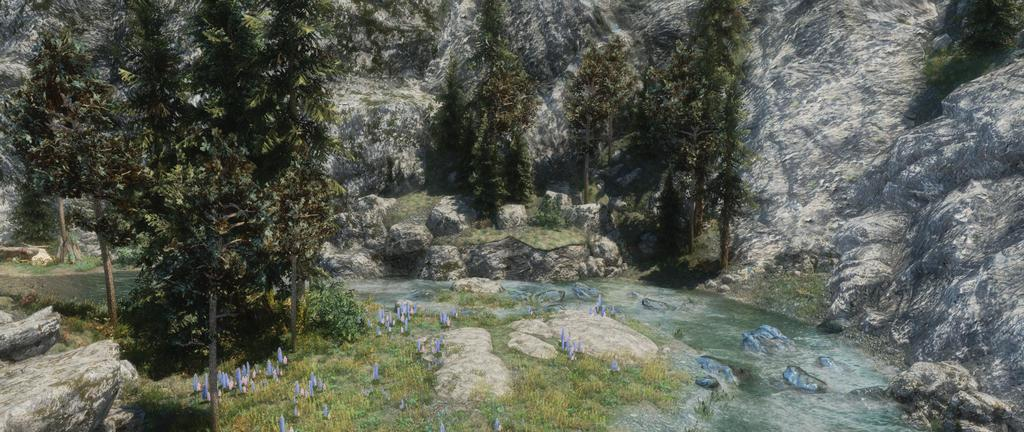What type of natural environment is depicted in the image? The image features greenery, rocks, and water, suggesting a natural setting. Can you describe the water in the image? The water is visible at the bottom side of the image. What can be seen in the background of the image? There are trees and mountains in the background of the image. What type of stick is the son using to direct the army in the image? There is no stick, son, or army present in the image. 